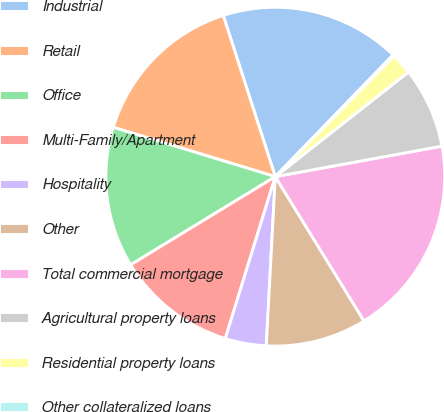Convert chart. <chart><loc_0><loc_0><loc_500><loc_500><pie_chart><fcel>Industrial<fcel>Retail<fcel>Office<fcel>Multi-Family/Apartment<fcel>Hospitality<fcel>Other<fcel>Total commercial mortgage<fcel>Agricultural property loans<fcel>Residential property loans<fcel>Other collateralized loans<nl><fcel>17.21%<fcel>15.32%<fcel>13.42%<fcel>11.52%<fcel>3.92%<fcel>9.62%<fcel>19.11%<fcel>7.72%<fcel>2.03%<fcel>0.13%<nl></chart> 